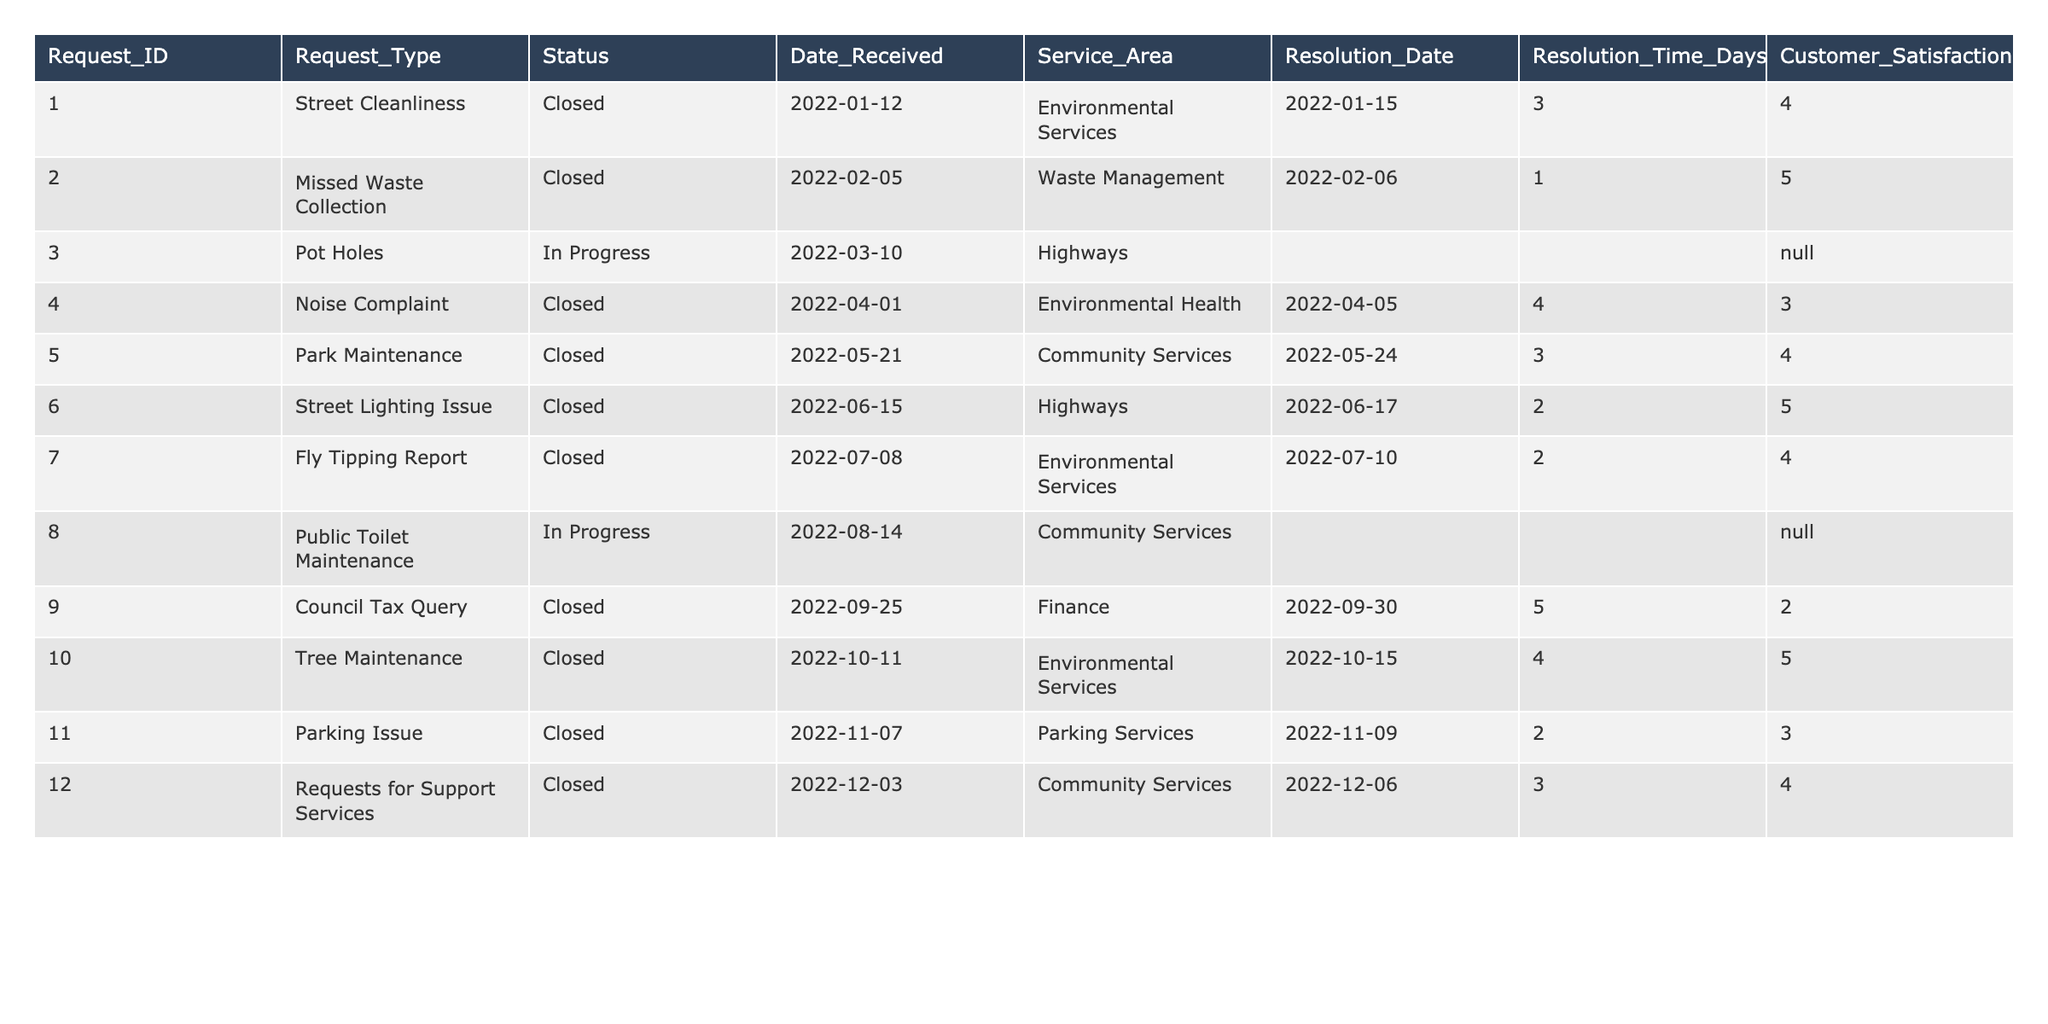What is the total number of community service requests made in 2022? There are 12 rows in the table, which represent 12 different service requests recorded in 2022.
Answer: 12 How many requests are currently "In Progress"? The table shows 2 requests with the status "In Progress": Request_IDs 3 and 8.
Answer: 2 What was the average resolution time for closed requests? First, sum the resolution times for the closed requests (3 + 1 + 4 + 3 + 2 + 5 + 4 + 2 + 3 = 27). There are 9 closed requests, so the average resolution time is 27 / 9 = 3.
Answer: 3 What is the customer satisfaction score for the request with the highest resolution time? Looking at the 'Resolution_Time_Days' for closed requests, the highest is 5 days for requests 2 and 10. The corresponding customer satisfaction scores for these are both 5.
Answer: 5 Is there any request type with a customer satisfaction score less than 3? Yes, the 'Council Tax Query' has a satisfaction score of 2, which is less than 3.
Answer: Yes Which service area had the most requests in 2022? Count the requests by service area: Environmental Services has 4, Waste Management has 1, Highways has 2, Environmental Health has 1, Community Services has 3, and Parking Services has 1. The highest count is 4 in Environmental Services.
Answer: Environmental Services What is the median customer satisfaction score of all closed requests? The customer satisfaction scores for closed requests are 4, 5, 3, 4, 5, 3, 4, and 2. Arranging these in order gives 2, 3, 3, 4, 4, 4, 5, 5. The median is the average of the 4th and 5th scores, which is (4 + 4) / 2 = 4.
Answer: 4 Was there any request without a resolution date? Yes, there are 2 requests (IDs 3 and 8) that currently do not have a resolution date.
Answer: Yes Which type of request has the highest customer satisfaction score? The highest customer satisfaction score is 5, achieved by the requests for 'Missed Waste Collection', 'Street Lighting Issue', and 'Tree Maintenance'.
Answer: Missed Waste Collection, Street Lighting Issue, and Tree Maintenance How many service requests were resolved in less than 3 days? The requests resolved in less than 3 days are Request_IDs 2 (1 day), 6 (2 days), and 1 (3 days). Therefore, 2 requests were resolved in less than 3 days.
Answer: 2 What was the most common status for requests in the table? The status "Closed" appears 9 times, while "In Progress" appears 2 times. Thus, "Closed" is the most common status.
Answer: Closed 